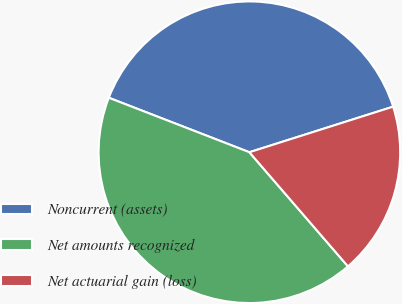Convert chart. <chart><loc_0><loc_0><loc_500><loc_500><pie_chart><fcel>Noncurrent (assets)<fcel>Net amounts recognized<fcel>Net actuarial gain (loss)<nl><fcel>39.23%<fcel>42.22%<fcel>18.55%<nl></chart> 